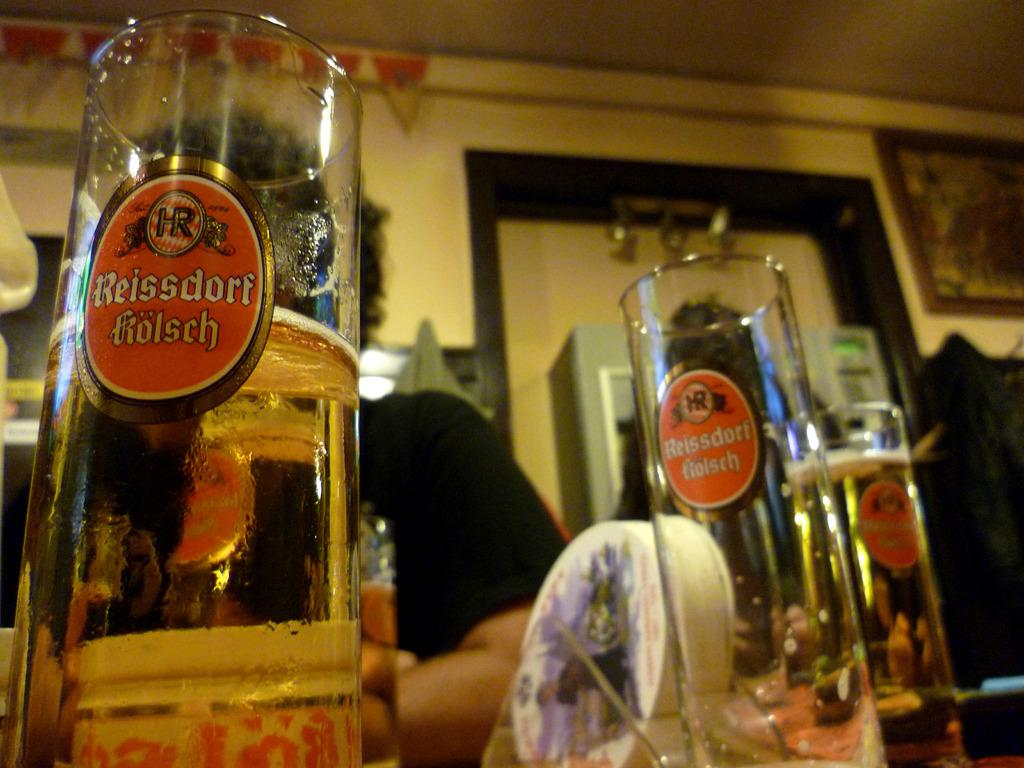<image>
Relay a brief, clear account of the picture shown. Pints of the beer reissdorf kolsch sit on the bar. 